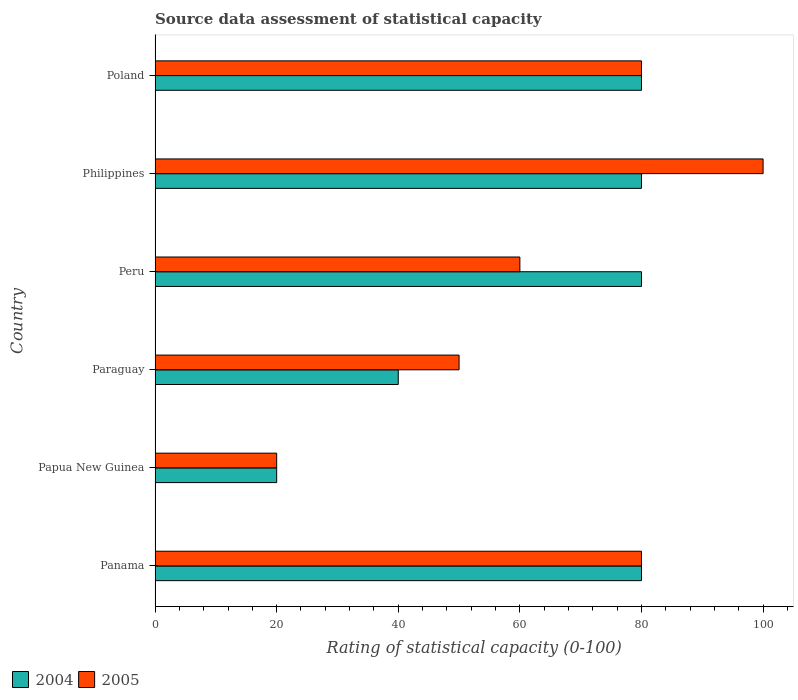Are the number of bars per tick equal to the number of legend labels?
Your response must be concise. Yes. Are the number of bars on each tick of the Y-axis equal?
Offer a very short reply. Yes. What is the label of the 3rd group of bars from the top?
Ensure brevity in your answer.  Peru. In how many cases, is the number of bars for a given country not equal to the number of legend labels?
Provide a succinct answer. 0. Across all countries, what is the maximum rating of statistical capacity in 2004?
Provide a short and direct response. 80. In which country was the rating of statistical capacity in 2004 minimum?
Offer a very short reply. Papua New Guinea. What is the total rating of statistical capacity in 2004 in the graph?
Ensure brevity in your answer.  380. What is the difference between the rating of statistical capacity in 2005 in Panama and that in Papua New Guinea?
Your answer should be compact. 60. What is the average rating of statistical capacity in 2004 per country?
Make the answer very short. 63.33. What is the difference between the rating of statistical capacity in 2004 and rating of statistical capacity in 2005 in Panama?
Your answer should be compact. 0. In how many countries, is the rating of statistical capacity in 2004 greater than 84 ?
Make the answer very short. 0. What is the ratio of the rating of statistical capacity in 2004 in Papua New Guinea to that in Poland?
Provide a short and direct response. 0.25. Is the rating of statistical capacity in 2004 in Papua New Guinea less than that in Paraguay?
Provide a succinct answer. Yes. What is the difference between the highest and the second highest rating of statistical capacity in 2005?
Provide a short and direct response. 20. What is the difference between the highest and the lowest rating of statistical capacity in 2004?
Offer a very short reply. 60. In how many countries, is the rating of statistical capacity in 2004 greater than the average rating of statistical capacity in 2004 taken over all countries?
Offer a terse response. 4. What is the difference between two consecutive major ticks on the X-axis?
Ensure brevity in your answer.  20. Are the values on the major ticks of X-axis written in scientific E-notation?
Offer a very short reply. No. Does the graph contain any zero values?
Give a very brief answer. No. How many legend labels are there?
Ensure brevity in your answer.  2. What is the title of the graph?
Provide a succinct answer. Source data assessment of statistical capacity. Does "1975" appear as one of the legend labels in the graph?
Keep it short and to the point. No. What is the label or title of the X-axis?
Provide a short and direct response. Rating of statistical capacity (0-100). What is the Rating of statistical capacity (0-100) in 2005 in Panama?
Your answer should be very brief. 80. What is the Rating of statistical capacity (0-100) of 2004 in Papua New Guinea?
Provide a short and direct response. 20. What is the Rating of statistical capacity (0-100) in 2004 in Paraguay?
Provide a succinct answer. 40. What is the Rating of statistical capacity (0-100) of 2005 in Paraguay?
Keep it short and to the point. 50. What is the Rating of statistical capacity (0-100) in 2004 in Peru?
Offer a very short reply. 80. What is the Rating of statistical capacity (0-100) of 2005 in Peru?
Offer a terse response. 60. What is the Rating of statistical capacity (0-100) of 2005 in Philippines?
Your response must be concise. 100. What is the Rating of statistical capacity (0-100) of 2004 in Poland?
Offer a terse response. 80. What is the Rating of statistical capacity (0-100) in 2005 in Poland?
Keep it short and to the point. 80. Across all countries, what is the minimum Rating of statistical capacity (0-100) in 2005?
Provide a succinct answer. 20. What is the total Rating of statistical capacity (0-100) of 2004 in the graph?
Provide a short and direct response. 380. What is the total Rating of statistical capacity (0-100) of 2005 in the graph?
Give a very brief answer. 390. What is the difference between the Rating of statistical capacity (0-100) in 2005 in Panama and that in Paraguay?
Your response must be concise. 30. What is the difference between the Rating of statistical capacity (0-100) in 2004 in Panama and that in Peru?
Your response must be concise. 0. What is the difference between the Rating of statistical capacity (0-100) in 2004 in Panama and that in Philippines?
Provide a short and direct response. 0. What is the difference between the Rating of statistical capacity (0-100) in 2005 in Panama and that in Philippines?
Make the answer very short. -20. What is the difference between the Rating of statistical capacity (0-100) in 2005 in Papua New Guinea and that in Paraguay?
Make the answer very short. -30. What is the difference between the Rating of statistical capacity (0-100) of 2004 in Papua New Guinea and that in Peru?
Make the answer very short. -60. What is the difference between the Rating of statistical capacity (0-100) in 2004 in Papua New Guinea and that in Philippines?
Offer a very short reply. -60. What is the difference between the Rating of statistical capacity (0-100) in 2005 in Papua New Guinea and that in Philippines?
Offer a very short reply. -80. What is the difference between the Rating of statistical capacity (0-100) of 2004 in Papua New Guinea and that in Poland?
Make the answer very short. -60. What is the difference between the Rating of statistical capacity (0-100) of 2005 in Papua New Guinea and that in Poland?
Ensure brevity in your answer.  -60. What is the difference between the Rating of statistical capacity (0-100) in 2004 in Paraguay and that in Peru?
Offer a very short reply. -40. What is the difference between the Rating of statistical capacity (0-100) in 2005 in Paraguay and that in Peru?
Provide a succinct answer. -10. What is the difference between the Rating of statistical capacity (0-100) of 2004 in Paraguay and that in Philippines?
Provide a short and direct response. -40. What is the difference between the Rating of statistical capacity (0-100) in 2005 in Paraguay and that in Philippines?
Make the answer very short. -50. What is the difference between the Rating of statistical capacity (0-100) of 2005 in Paraguay and that in Poland?
Keep it short and to the point. -30. What is the difference between the Rating of statistical capacity (0-100) in 2005 in Peru and that in Philippines?
Offer a terse response. -40. What is the difference between the Rating of statistical capacity (0-100) of 2004 in Peru and that in Poland?
Offer a very short reply. 0. What is the difference between the Rating of statistical capacity (0-100) of 2004 in Panama and the Rating of statistical capacity (0-100) of 2005 in Papua New Guinea?
Make the answer very short. 60. What is the difference between the Rating of statistical capacity (0-100) of 2004 in Panama and the Rating of statistical capacity (0-100) of 2005 in Paraguay?
Offer a very short reply. 30. What is the difference between the Rating of statistical capacity (0-100) of 2004 in Panama and the Rating of statistical capacity (0-100) of 2005 in Poland?
Your answer should be compact. 0. What is the difference between the Rating of statistical capacity (0-100) in 2004 in Papua New Guinea and the Rating of statistical capacity (0-100) in 2005 in Paraguay?
Your answer should be compact. -30. What is the difference between the Rating of statistical capacity (0-100) of 2004 in Papua New Guinea and the Rating of statistical capacity (0-100) of 2005 in Philippines?
Your answer should be very brief. -80. What is the difference between the Rating of statistical capacity (0-100) of 2004 in Papua New Guinea and the Rating of statistical capacity (0-100) of 2005 in Poland?
Give a very brief answer. -60. What is the difference between the Rating of statistical capacity (0-100) in 2004 in Paraguay and the Rating of statistical capacity (0-100) in 2005 in Philippines?
Your response must be concise. -60. What is the difference between the Rating of statistical capacity (0-100) of 2004 in Philippines and the Rating of statistical capacity (0-100) of 2005 in Poland?
Offer a terse response. 0. What is the average Rating of statistical capacity (0-100) of 2004 per country?
Offer a terse response. 63.33. What is the difference between the Rating of statistical capacity (0-100) in 2004 and Rating of statistical capacity (0-100) in 2005 in Papua New Guinea?
Provide a short and direct response. 0. What is the difference between the Rating of statistical capacity (0-100) of 2004 and Rating of statistical capacity (0-100) of 2005 in Peru?
Provide a short and direct response. 20. What is the difference between the Rating of statistical capacity (0-100) of 2004 and Rating of statistical capacity (0-100) of 2005 in Philippines?
Keep it short and to the point. -20. What is the ratio of the Rating of statistical capacity (0-100) in 2005 in Panama to that in Peru?
Your answer should be very brief. 1.33. What is the ratio of the Rating of statistical capacity (0-100) in 2004 in Panama to that in Philippines?
Keep it short and to the point. 1. What is the ratio of the Rating of statistical capacity (0-100) of 2005 in Panama to that in Philippines?
Give a very brief answer. 0.8. What is the ratio of the Rating of statistical capacity (0-100) in 2005 in Papua New Guinea to that in Peru?
Keep it short and to the point. 0.33. What is the ratio of the Rating of statistical capacity (0-100) in 2004 in Papua New Guinea to that in Poland?
Your answer should be compact. 0.25. What is the ratio of the Rating of statistical capacity (0-100) of 2004 in Paraguay to that in Poland?
Make the answer very short. 0.5. What is the ratio of the Rating of statistical capacity (0-100) of 2005 in Paraguay to that in Poland?
Ensure brevity in your answer.  0.62. What is the ratio of the Rating of statistical capacity (0-100) of 2004 in Peru to that in Poland?
Your response must be concise. 1. What is the difference between the highest and the lowest Rating of statistical capacity (0-100) in 2005?
Provide a short and direct response. 80. 